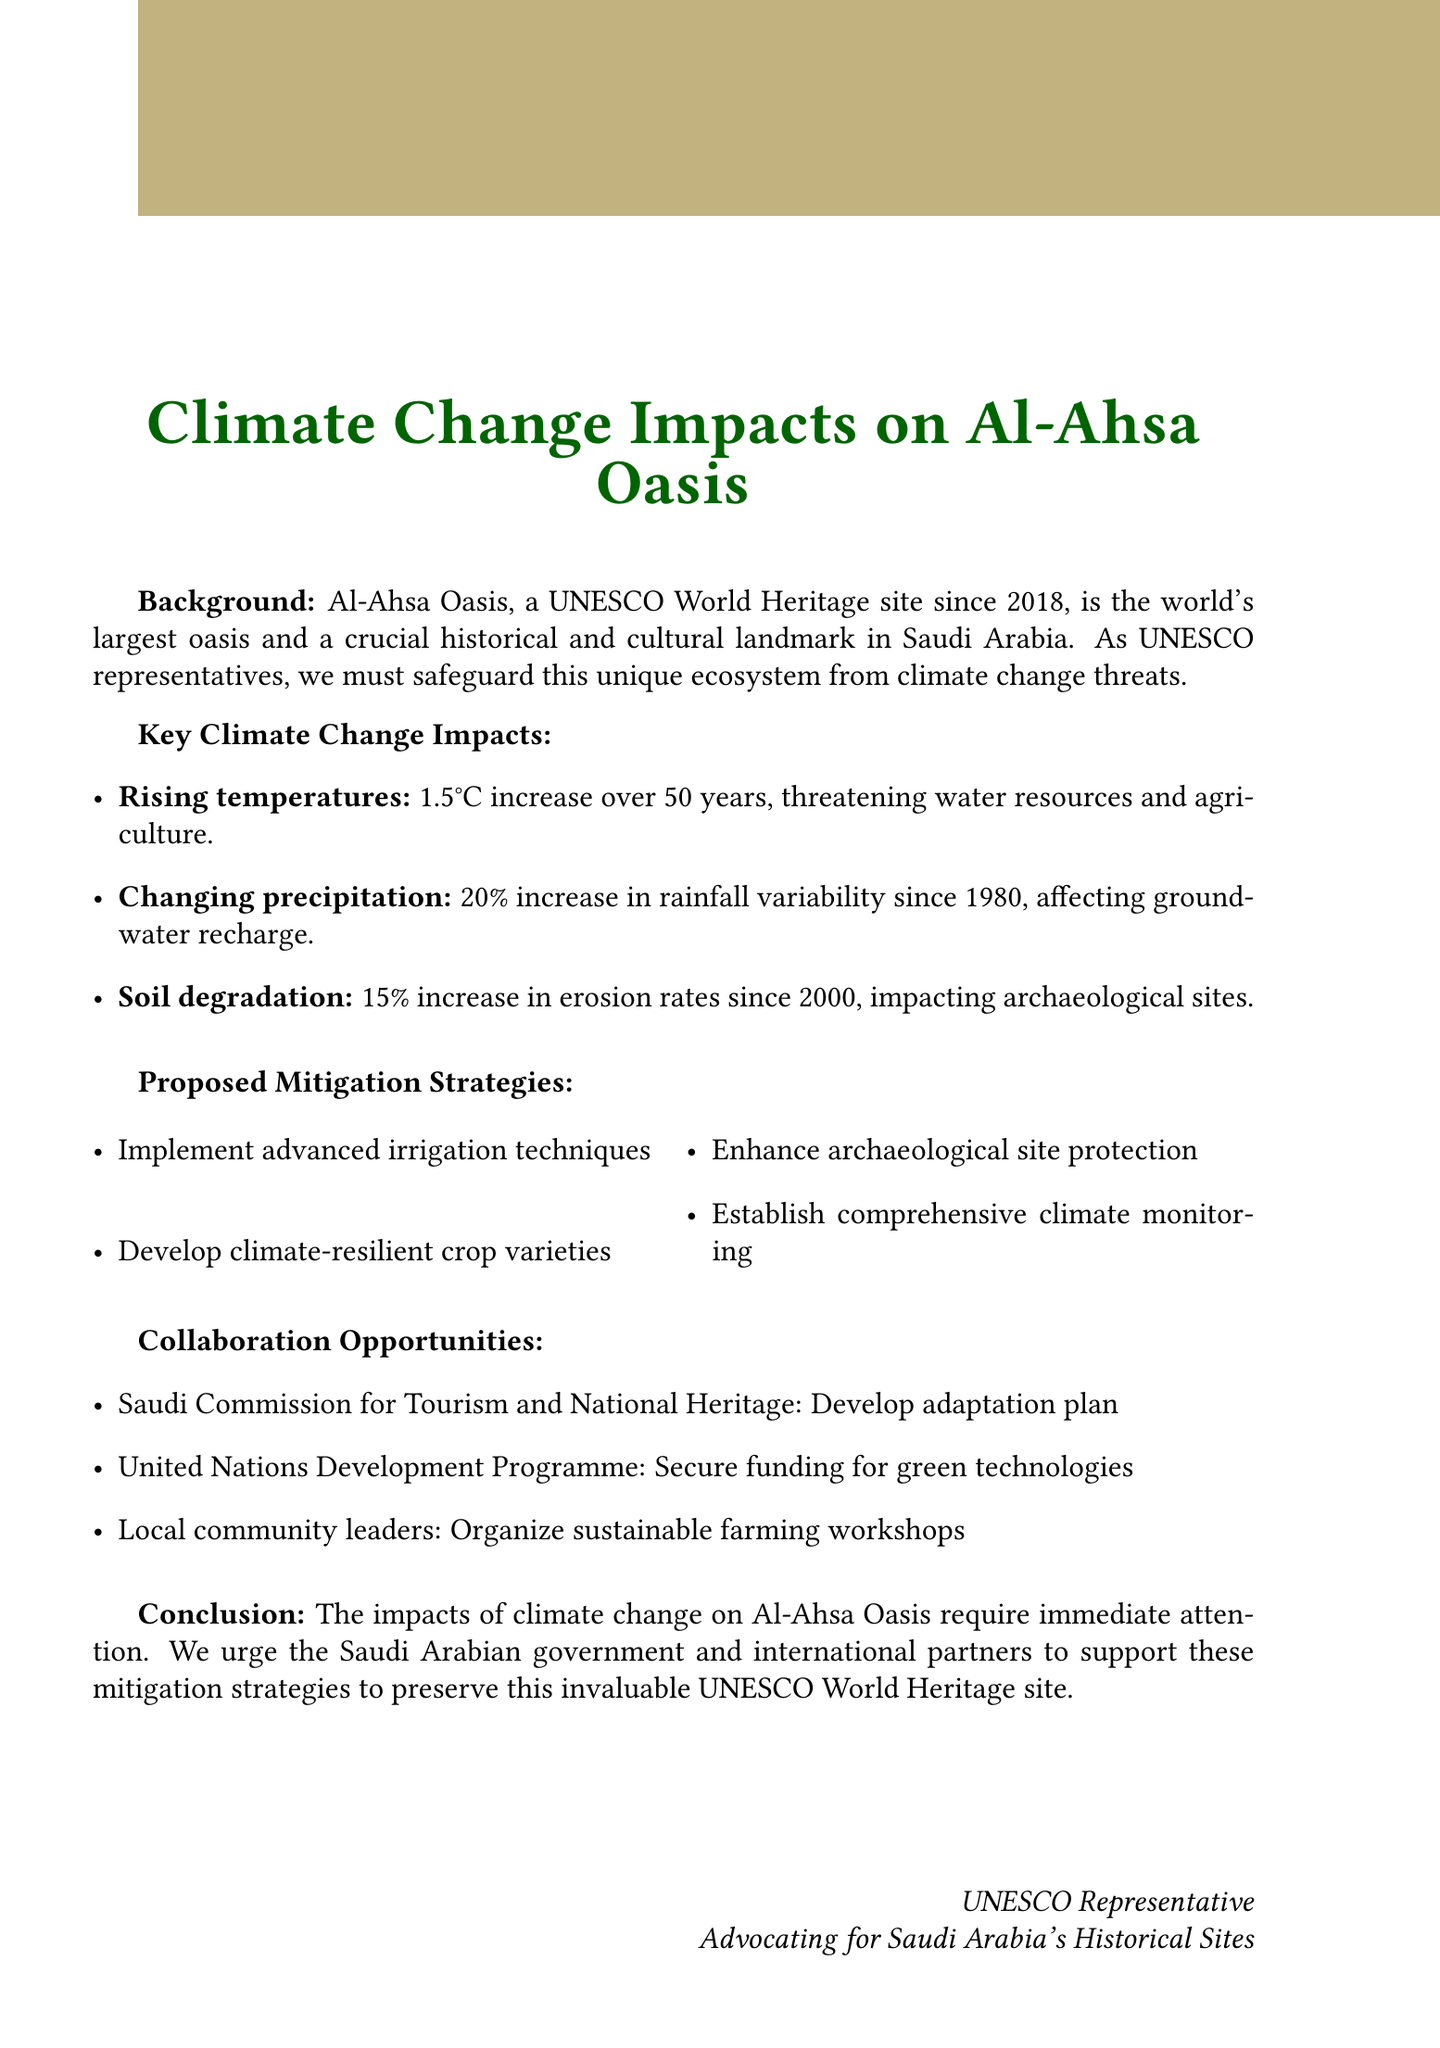What year was Al-Ahsa Oasis designated as a UNESCO World Heritage site? Al-Ahsa Oasis was designated as a UNESCO World Heritage site in 2018.
Answer: 2018 What is the average temperature increase in Al-Ahsa over the past 50 years? The average temperature in Al-Ahsa has risen by 1.5°C over the past 50 years.
Answer: 1.5°C What percentage has rainfall variability increased in the Eastern Province since 1980? Rainfall variability has increased by 20% in the Eastern Province since 1980.
Answer: 20% What is one suggested strategy to enhance agricultural productivity? One suggested strategy is to implement advanced irrigation techniques.
Answer: Advanced irrigation techniques Which partner is mentioned for developing a climate change adaptation plan? The Saudi Commission for Tourism and National Heritage is mentioned for developing the adaptation plan.
Answer: Saudi Commission for Tourism and National Heritage What is the potential impact of establishing a comprehensive climate monitoring system? Establishing a comprehensive climate monitoring system can improve early warning systems.
Answer: Improve early warning systems What has been observed regarding soil erosion rates in Al-Ahsa since 2000? The Saudi Geological Survey has observed a 15% increase in soil erosion rates since 2000.
Answer: 15% What does the conclusion urge the Saudi Arabian government to do? The conclusion urges the Saudi Arabian government to support and implement these mitigation strategies.
Answer: Support and implement mitigation strategies Which historical site is specifically mentioned for regular monitoring? Jawatha Mosque is specifically mentioned for regular monitoring.
Answer: Jawatha Mosque 